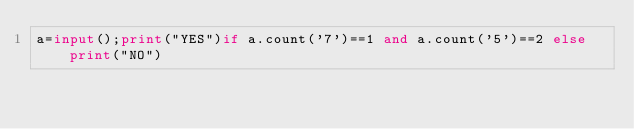Convert code to text. <code><loc_0><loc_0><loc_500><loc_500><_Python_>a=input();print("YES")if a.count('7')==1 and a.count('5')==2 else print("NO")</code> 